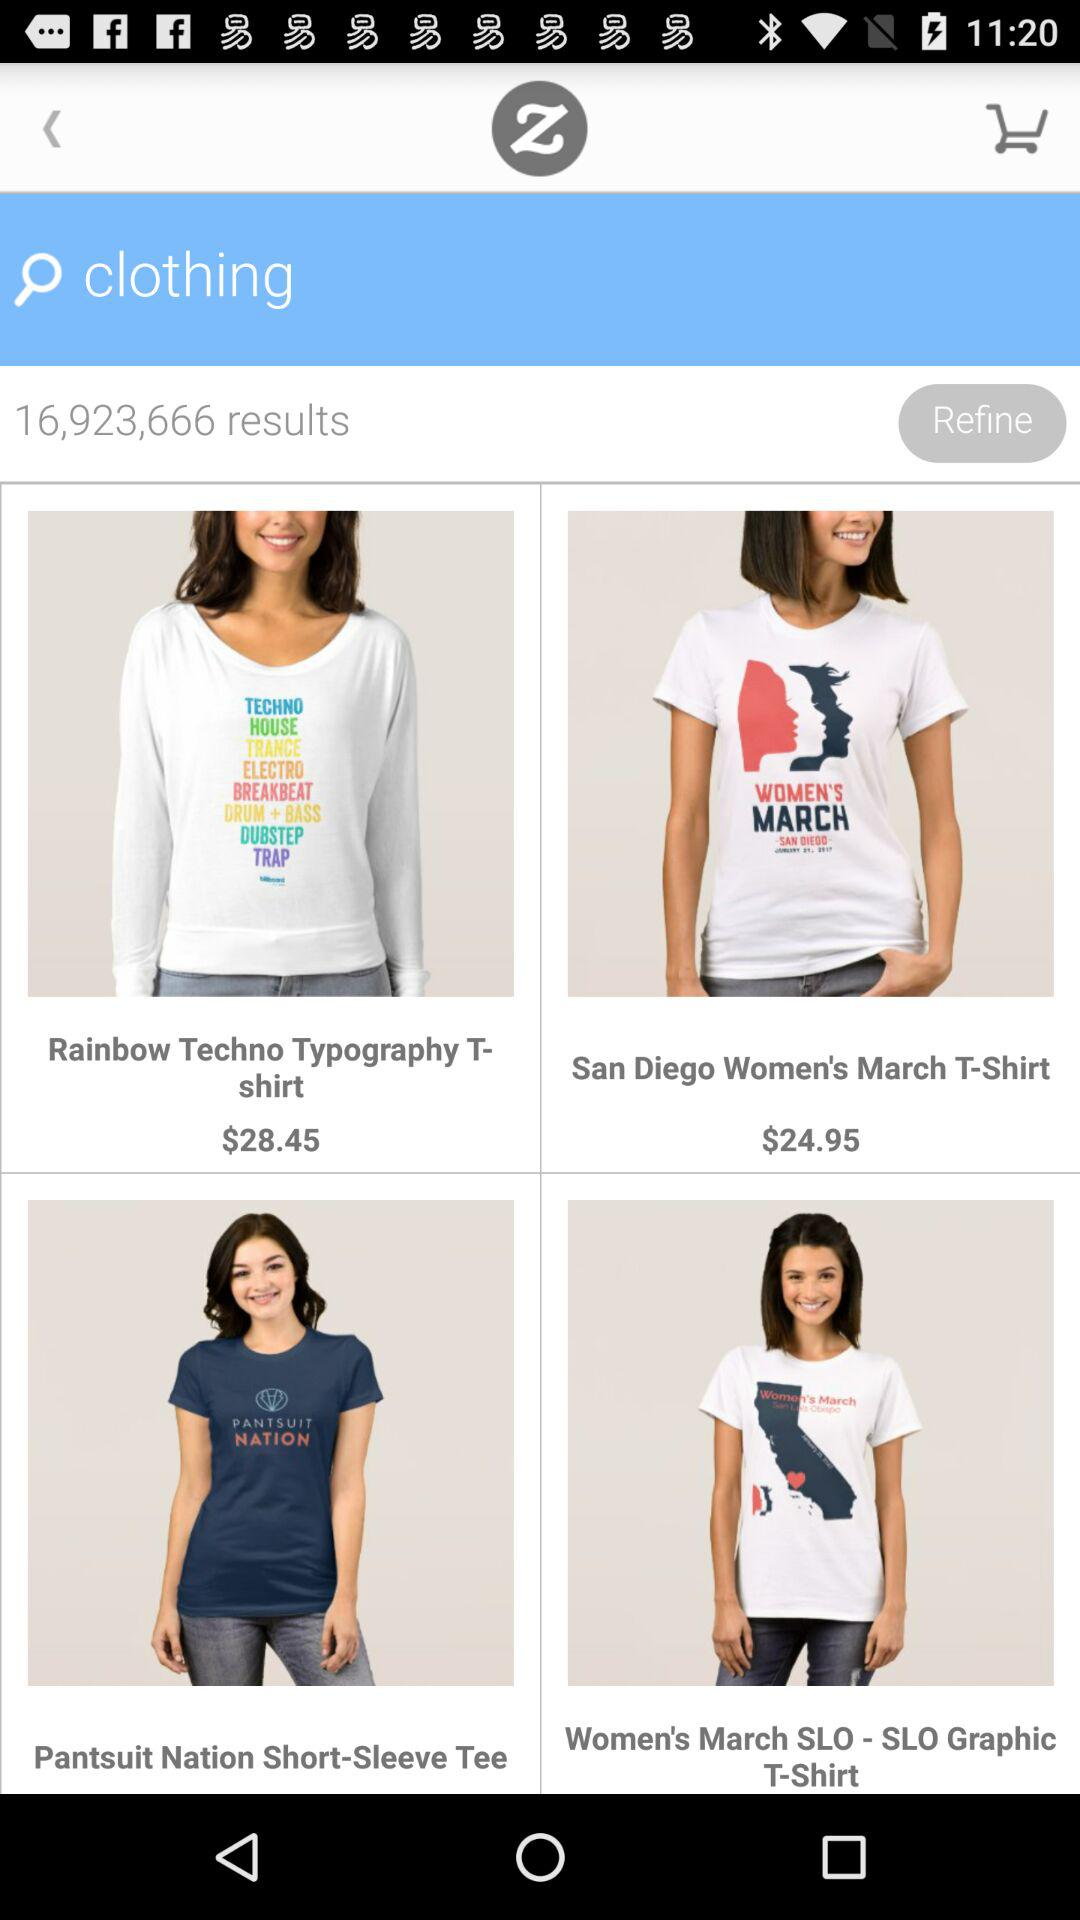What is the total number of search results? The total number of results is 16,923,666. 